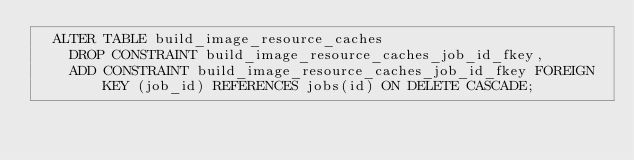<code> <loc_0><loc_0><loc_500><loc_500><_SQL_>  ALTER TABLE build_image_resource_caches
    DROP CONSTRAINT build_image_resource_caches_job_id_fkey,
    ADD CONSTRAINT build_image_resource_caches_job_id_fkey FOREIGN KEY (job_id) REFERENCES jobs(id) ON DELETE CASCADE;
</code> 